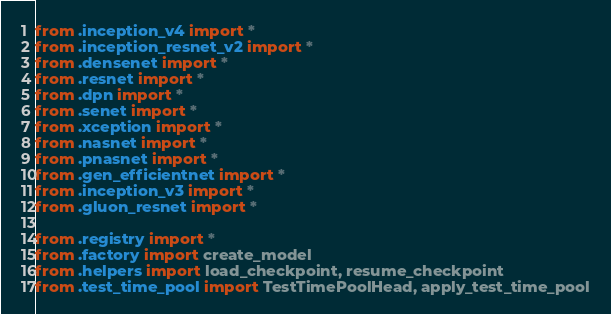<code> <loc_0><loc_0><loc_500><loc_500><_Python_>from .inception_v4 import *
from .inception_resnet_v2 import *
from .densenet import *
from .resnet import *
from .dpn import *
from .senet import *
from .xception import *
from .nasnet import *
from .pnasnet import *
from .gen_efficientnet import *
from .inception_v3 import *
from .gluon_resnet import *

from .registry import *
from .factory import create_model
from .helpers import load_checkpoint, resume_checkpoint
from .test_time_pool import TestTimePoolHead, apply_test_time_pool
</code> 